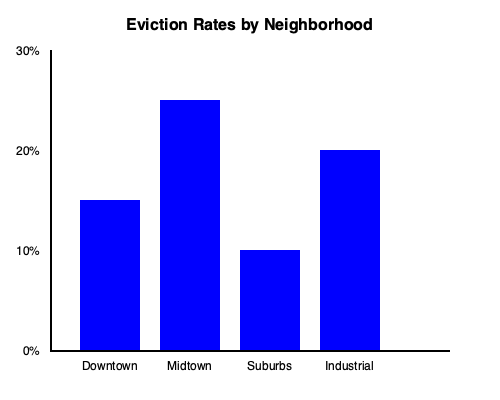Based on the bar graph showing eviction rates across different neighborhoods, which area has the highest eviction rate, and what potential factors might contribute to this disparity in the context of affordable housing and tenant rights? To answer this question, we need to analyze the graph and consider socioeconomic factors related to housing:

1. Interpret the graph:
   - The y-axis represents eviction rates from 0% to 30%.
   - The x-axis shows four neighborhoods: Downtown, Midtown, Suburbs, and Industrial.

2. Identify the highest eviction rate:
   - Downtown: approximately 15%
   - Midtown: approximately 25%
   - Suburbs: approximately 10%
   - Industrial: approximately 20%
   - Midtown has the highest bar, indicating the highest eviction rate at about 25%.

3. Consider potential factors contributing to high eviction rates in Midtown:
   a) Gentrification: Midtown areas often experience rapid development, leading to increased property values and rents.
   b) Income disparity: A mix of high-income and low-income residents may create pressure on affordable housing.
   c) Older housing stock: Midtown might have aging buildings with maintenance issues, leading to disputes.
   d) Lack of rent control: Absence of rent stabilization policies could allow for sudden rent increases.
   e) High demand: Desirable location may lead to landlords favoring higher-paying tenants.

4. Relate to affordable housing and tenant rights:
   - The high eviction rate in Midtown highlights the need for stronger tenant protections and affordable housing initiatives.
   - Policies such as rent control, just-cause eviction laws, and affordable housing mandates could help address this issue.
   - Community organizing and education about tenant rights could empower residents to resist unjust evictions.

5. Compare to other neighborhoods:
   - The lower eviction rates in Suburbs might indicate more stable, long-term residency or stronger tenant protections.
   - The Industrial area's moderately high rate could reflect the conversion of industrial spaces to residential use without adequate tenant safeguards.
Answer: Midtown has the highest eviction rate (25%), likely due to gentrification, income disparity, and lack of affordable housing policies. 